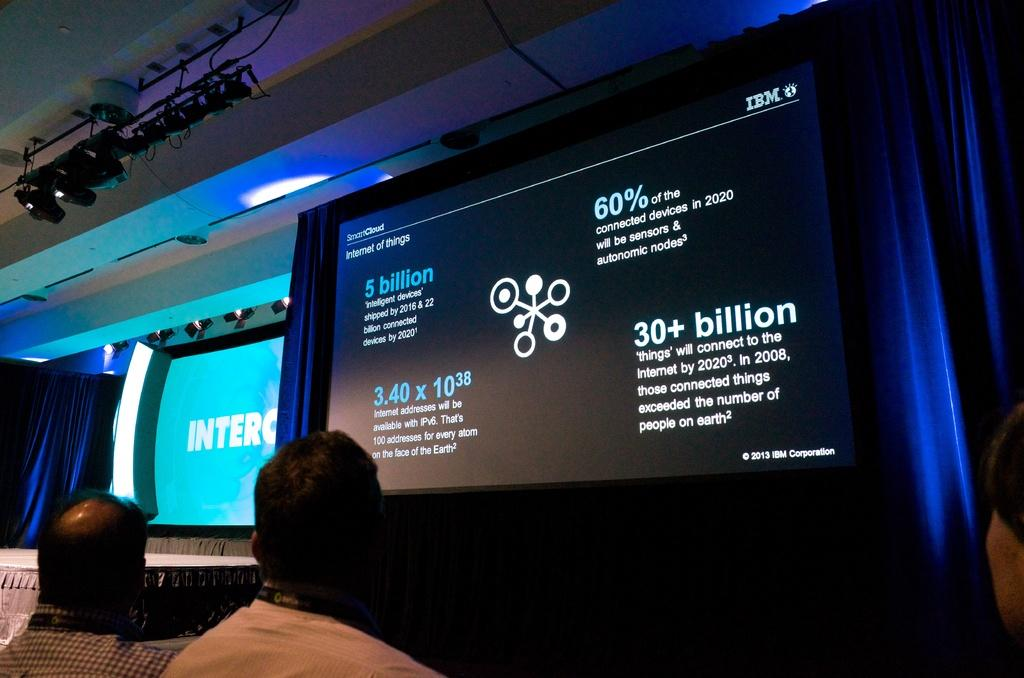How many people are sitting in the center of the image? There are three persons sitting in the center of the image. What can be seen in the background of the image? In the background of the image, there is a wall, a roof, lights, a curtain, screens, and other objects. Can you describe the setting where the people are sitting? The people are sitting in a room with a wall, roof, and various objects in the background. What type of bike is parked next to the people in the image? There is no bike present in the image; it only features three persons sitting in the center and various objects in the background. 